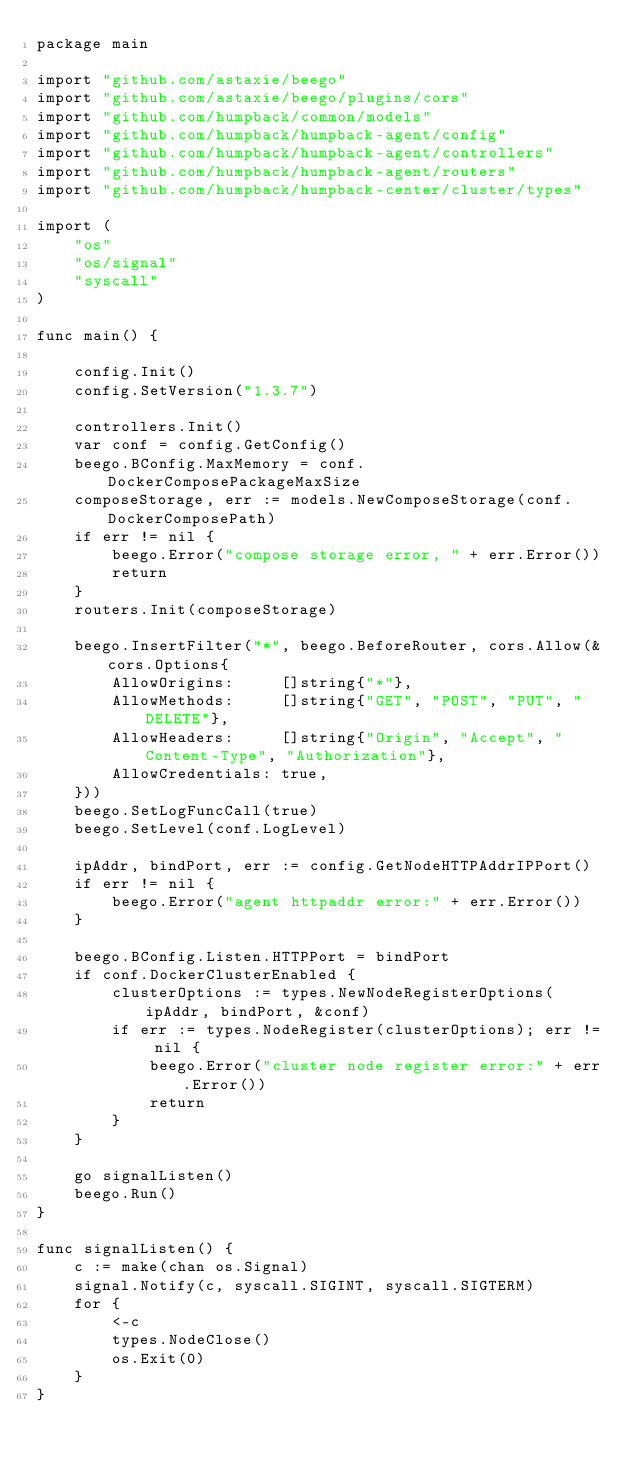Convert code to text. <code><loc_0><loc_0><loc_500><loc_500><_Go_>package main

import "github.com/astaxie/beego"
import "github.com/astaxie/beego/plugins/cors"
import "github.com/humpback/common/models"
import "github.com/humpback/humpback-agent/config"
import "github.com/humpback/humpback-agent/controllers"
import "github.com/humpback/humpback-agent/routers"
import "github.com/humpback/humpback-center/cluster/types"

import (
	"os"
	"os/signal"
	"syscall"
)

func main() {

	config.Init()
	config.SetVersion("1.3.7")

	controllers.Init()
	var conf = config.GetConfig()
	beego.BConfig.MaxMemory = conf.DockerComposePackageMaxSize
	composeStorage, err := models.NewComposeStorage(conf.DockerComposePath)
	if err != nil {
		beego.Error("compose storage error, " + err.Error())
		return
	}
	routers.Init(composeStorage)

	beego.InsertFilter("*", beego.BeforeRouter, cors.Allow(&cors.Options{
		AllowOrigins:     []string{"*"},
		AllowMethods:     []string{"GET", "POST", "PUT", "DELETE"},
		AllowHeaders:     []string{"Origin", "Accept", "Content-Type", "Authorization"},
		AllowCredentials: true,
	}))
	beego.SetLogFuncCall(true)
	beego.SetLevel(conf.LogLevel)

	ipAddr, bindPort, err := config.GetNodeHTTPAddrIPPort()
	if err != nil {
		beego.Error("agent httpaddr error:" + err.Error())
	}

	beego.BConfig.Listen.HTTPPort = bindPort
	if conf.DockerClusterEnabled {
		clusterOptions := types.NewNodeRegisterOptions(ipAddr, bindPort, &conf)
		if err := types.NodeRegister(clusterOptions); err != nil {
			beego.Error("cluster node register error:" + err.Error())
			return
		}
	}

	go signalListen()
	beego.Run()
}

func signalListen() {
	c := make(chan os.Signal)
	signal.Notify(c, syscall.SIGINT, syscall.SIGTERM)
	for {
		<-c
		types.NodeClose()
		os.Exit(0)
	}
}
</code> 